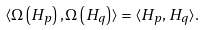Convert formula to latex. <formula><loc_0><loc_0><loc_500><loc_500>\langle \Omega \left ( H _ { p } \right ) , \Omega \left ( H _ { q } \right ) \rangle = \langle H _ { p } , H _ { q } \rangle .</formula> 